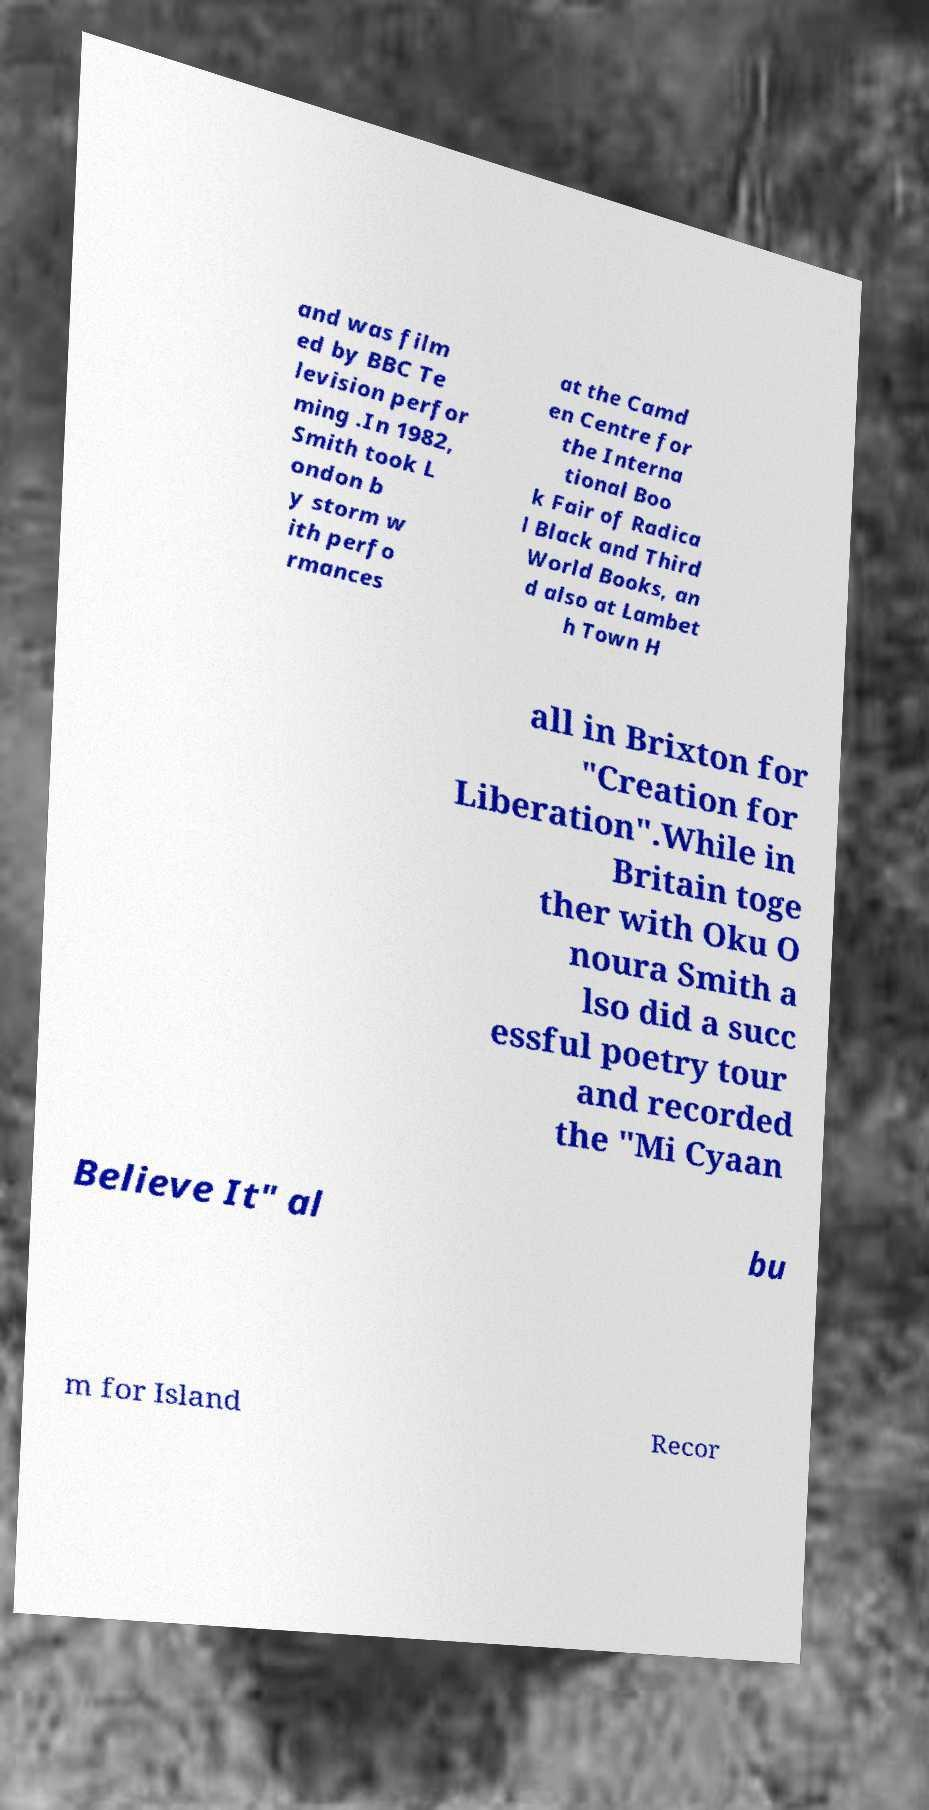Can you read and provide the text displayed in the image?This photo seems to have some interesting text. Can you extract and type it out for me? and was film ed by BBC Te levision perfor ming .In 1982, Smith took L ondon b y storm w ith perfo rmances at the Camd en Centre for the Interna tional Boo k Fair of Radica l Black and Third World Books, an d also at Lambet h Town H all in Brixton for "Creation for Liberation".While in Britain toge ther with Oku O noura Smith a lso did a succ essful poetry tour and recorded the "Mi Cyaan Believe It" al bu m for Island Recor 